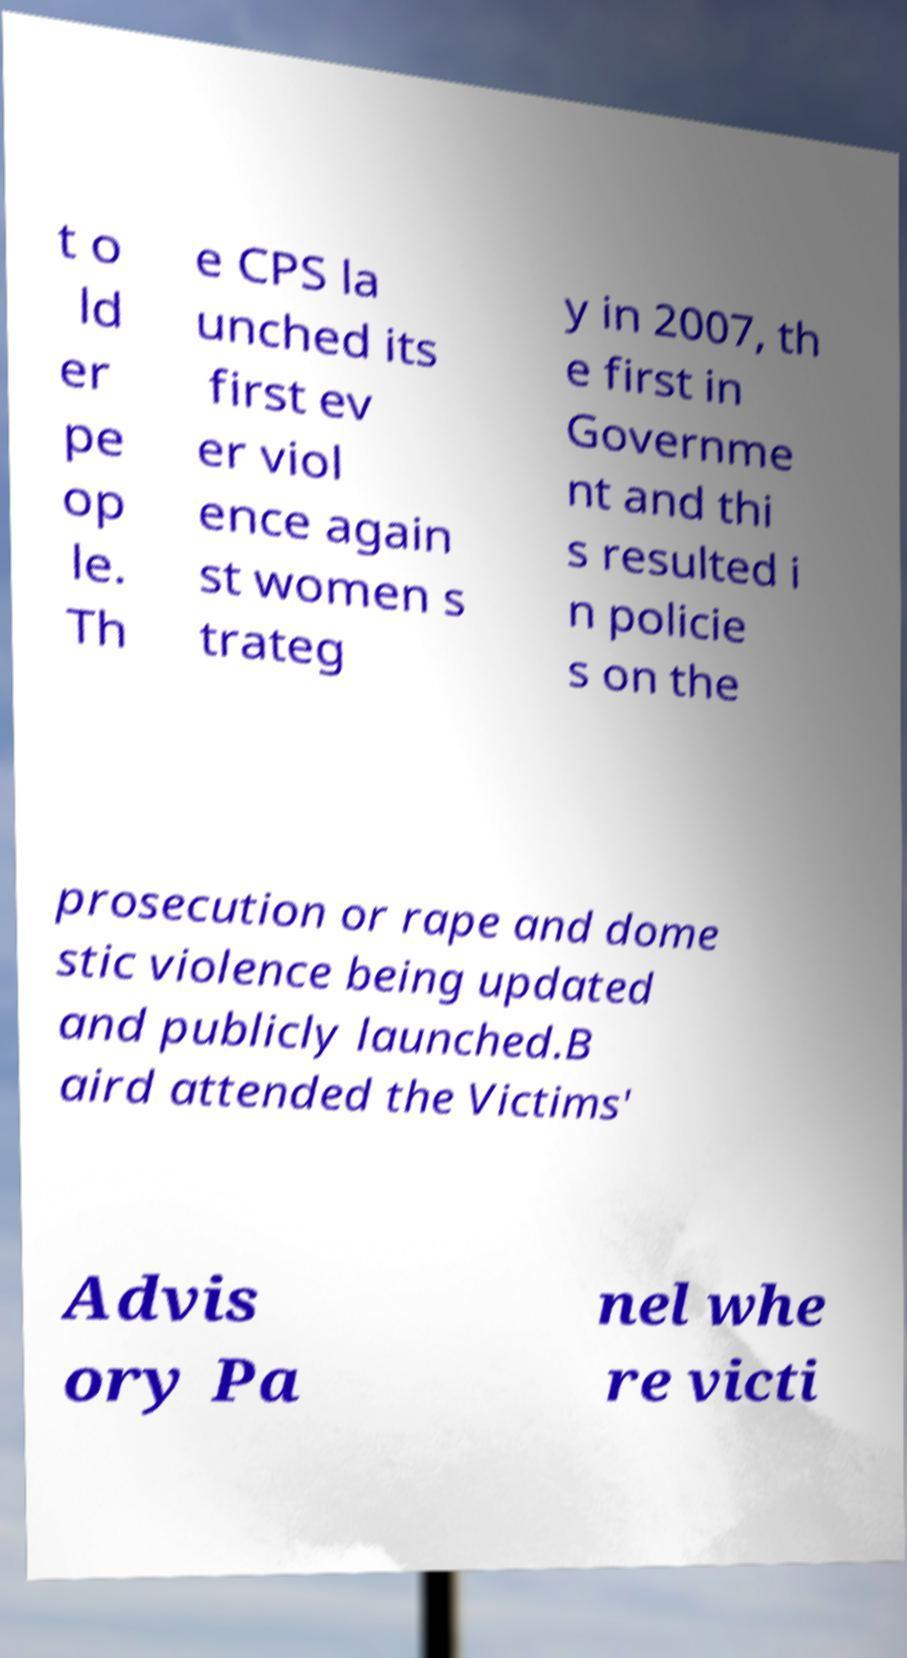Please read and relay the text visible in this image. What does it say? t o ld er pe op le. Th e CPS la unched its first ev er viol ence again st women s trateg y in 2007, th e first in Governme nt and thi s resulted i n policie s on the prosecution or rape and dome stic violence being updated and publicly launched.B aird attended the Victims' Advis ory Pa nel whe re victi 